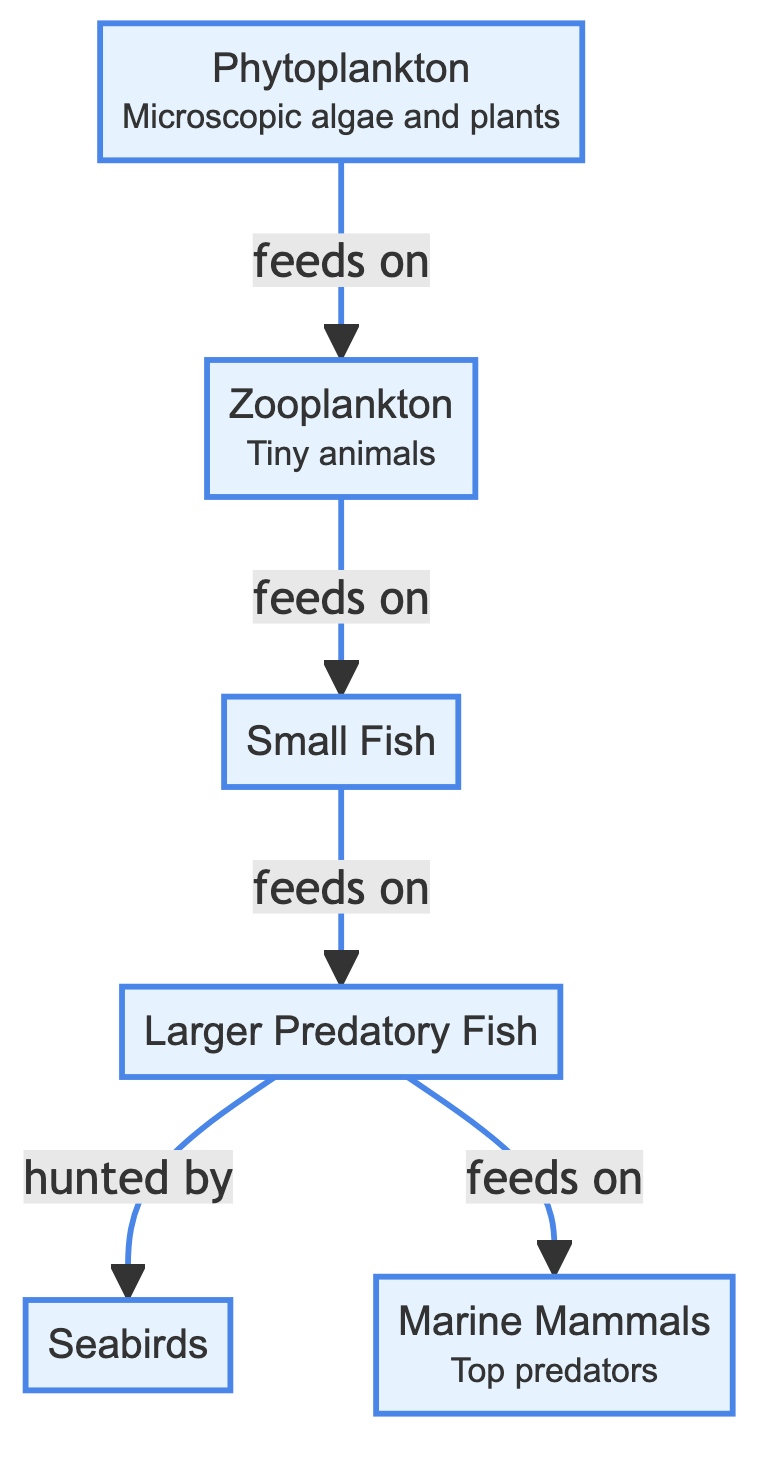What is the first organism in the food chain? The food chain starts with phytoplankton, which is indicated as the first organism in the diagram.
Answer: Phytoplankton How many organisms are fed on by larger predatory fish? The diagram shows that larger predatory fish are fed on by seabirds and that they also feed on marine mammals. They are involved in two relationships where they feed on one group and are fed on by another.
Answer: 2 What type of organism is zooplankton? Zooplankton is classified as tiny animals in the diagram, which is provided as a description.
Answer: Tiny animals Which organism feeds on small fish? From the diagram, it illustrates that larger predatory fish feed on small fish. This indicates a direct line of energy transfer between these two organisms.
Answer: Larger Predatory Fish What is the ultimate top predator in this marine food chain? The diagram indicates that marine mammals are classified as top predators, as they are shown at the end of the chain, where energy flows towards them.
Answer: Marine Mammals How many edges are there in this food chain? In the flowchart, the connections between the organisms represent edges. Counting these connections gives a total of five distinct feeding relationships (edges) within the food chain.
Answer: 5 What do zooplankton rely on for energy? The diagram shows that zooplankton feed on phytoplankton, which is their primary source of energy in this ecosystem.
Answer: Phytoplankton In the marine food chain, which organism is directly hunted by seabirds? The diagram indicates that seabirds hunt larger predatory fish, establishing a direct predator-prey relationship.
Answer: Larger Predatory Fish 